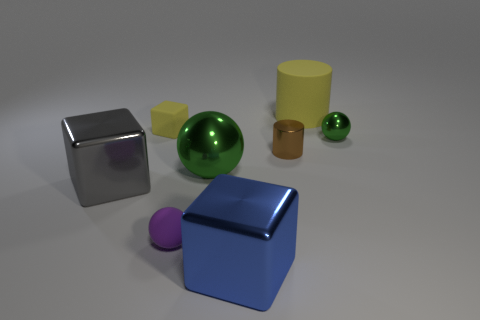How many gray things are the same shape as the small green object?
Your response must be concise. 0. Is the tiny sphere that is left of the large yellow cylinder made of the same material as the tiny block that is behind the small shiny cylinder?
Offer a very short reply. Yes. There is a yellow matte object that is left of the metal ball to the left of the big yellow thing; how big is it?
Provide a succinct answer. Small. Are there any other things that are the same size as the blue block?
Your response must be concise. Yes. What is the material of the yellow object that is the same shape as the tiny brown metallic object?
Offer a very short reply. Rubber. Do the tiny metal thing to the right of the big cylinder and the yellow thing that is in front of the large yellow rubber object have the same shape?
Your answer should be compact. No. Are there more yellow things than small gray balls?
Your answer should be very brief. Yes. The gray object is what size?
Give a very brief answer. Large. How many other objects are there of the same color as the small cube?
Your response must be concise. 1. Do the sphere on the right side of the small shiny cylinder and the big cylinder have the same material?
Ensure brevity in your answer.  No. 